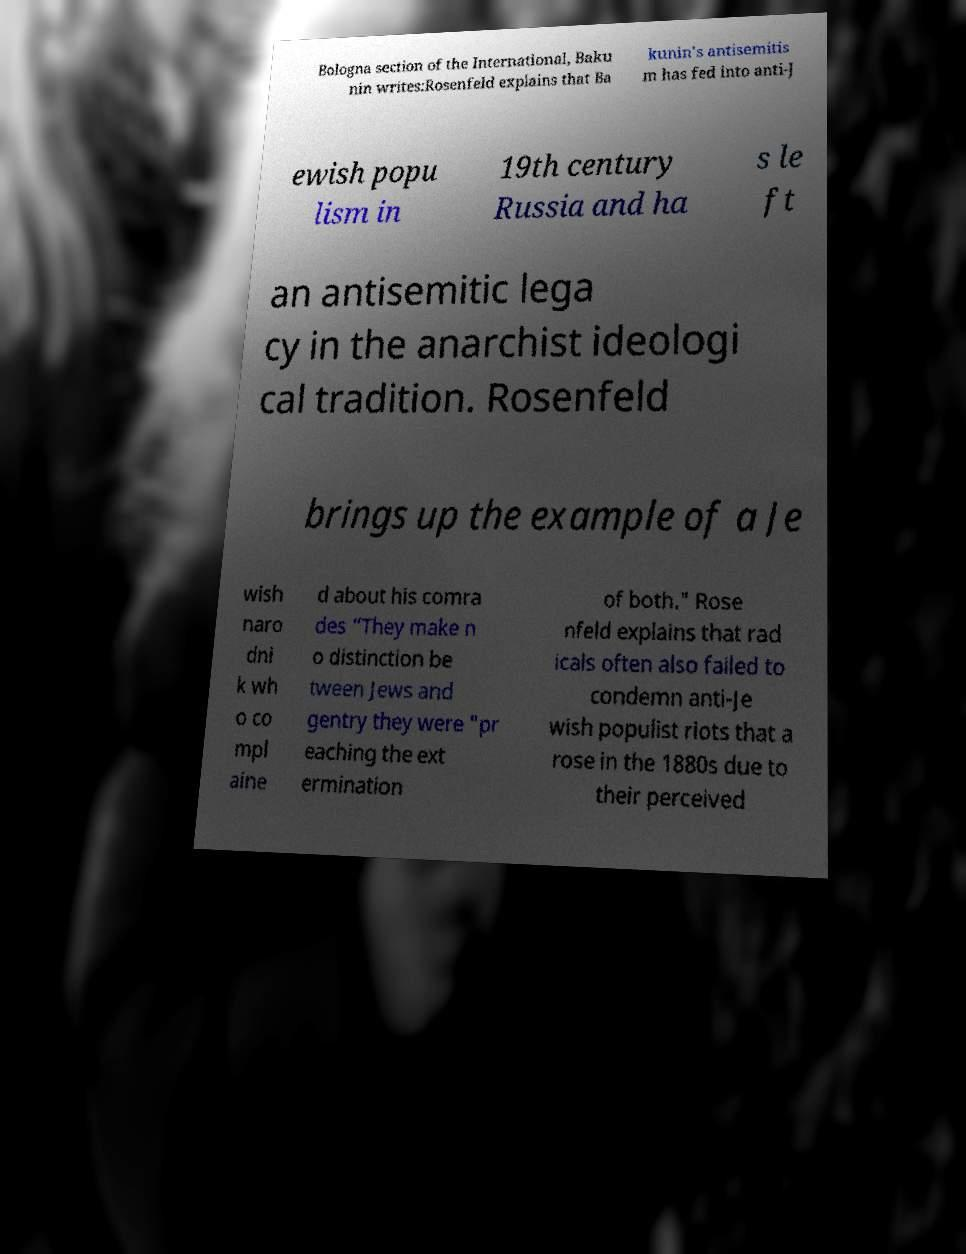There's text embedded in this image that I need extracted. Can you transcribe it verbatim? Bologna section of the International, Baku nin writes:Rosenfeld explains that Ba kunin's antisemitis m has fed into anti-J ewish popu lism in 19th century Russia and ha s le ft an antisemitic lega cy in the anarchist ideologi cal tradition. Rosenfeld brings up the example of a Je wish naro dni k wh o co mpl aine d about his comra des “They make n o distinction be tween Jews and gentry they were "pr eaching the ext ermination of both." Rose nfeld explains that rad icals often also failed to condemn anti-Je wish populist riots that a rose in the 1880s due to their perceived 